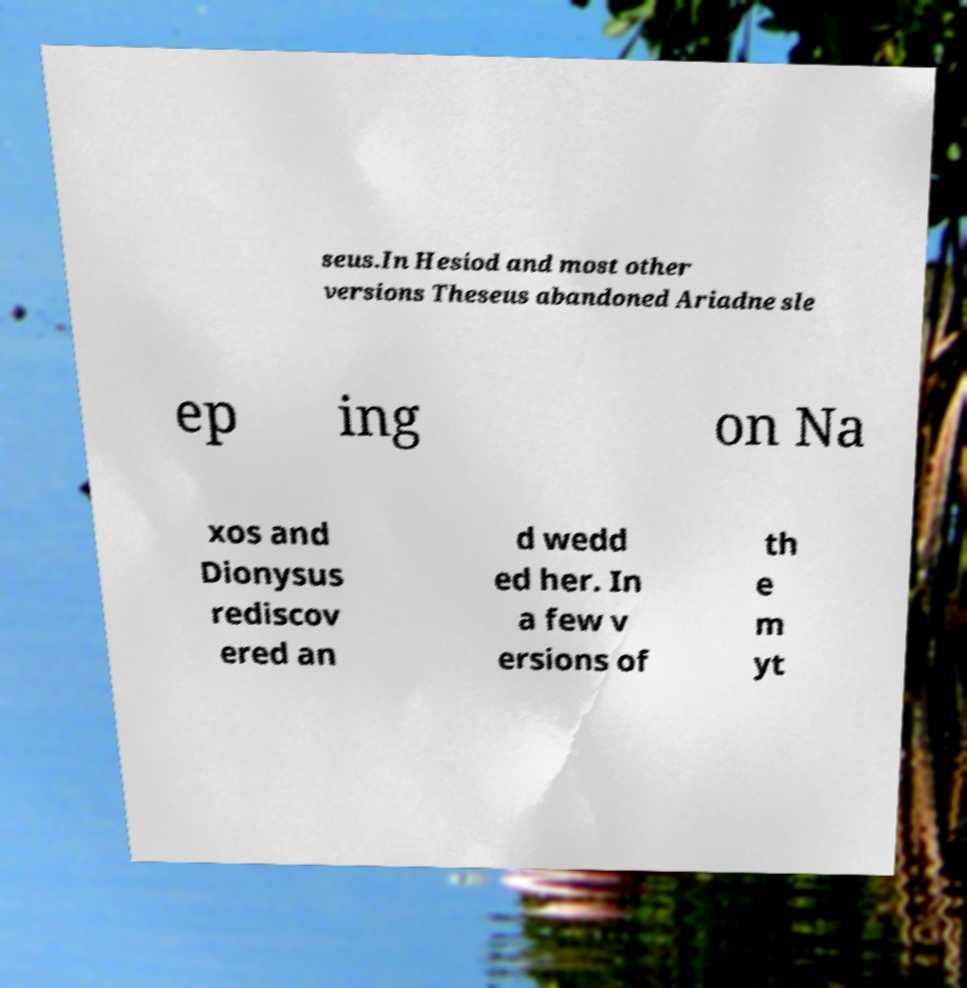Can you read and provide the text displayed in the image?This photo seems to have some interesting text. Can you extract and type it out for me? seus.In Hesiod and most other versions Theseus abandoned Ariadne sle ep ing on Na xos and Dionysus rediscov ered an d wedd ed her. In a few v ersions of th e m yt 